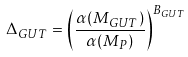<formula> <loc_0><loc_0><loc_500><loc_500>\Delta _ { G U T } = \left ( \frac { \alpha ( M _ { G U T } ) } { \alpha ( M _ { P } ) } \right ) ^ { B _ { G U T } }</formula> 